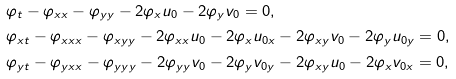Convert formula to latex. <formula><loc_0><loc_0><loc_500><loc_500>& \varphi _ { t } - \varphi _ { x x } - \varphi _ { y y } - 2 \varphi _ { x } u _ { 0 } - 2 \varphi _ { y } v _ { 0 } = 0 , \\ & \varphi _ { x t } - \varphi _ { x x x } - \varphi _ { x y y } - 2 \varphi _ { x x } u _ { 0 } - 2 \varphi _ { x } u _ { 0 x } - 2 \varphi _ { x y } v _ { 0 } - 2 \varphi _ { y } u _ { 0 y } = 0 , \\ & \varphi _ { y t } - \varphi _ { y x x } - \varphi _ { y y y } - 2 \varphi _ { y y } v _ { 0 } - 2 \varphi _ { y } v _ { 0 y } - 2 \varphi _ { x y } u _ { 0 } - 2 \varphi _ { x } v _ { 0 x } = 0 ,</formula> 